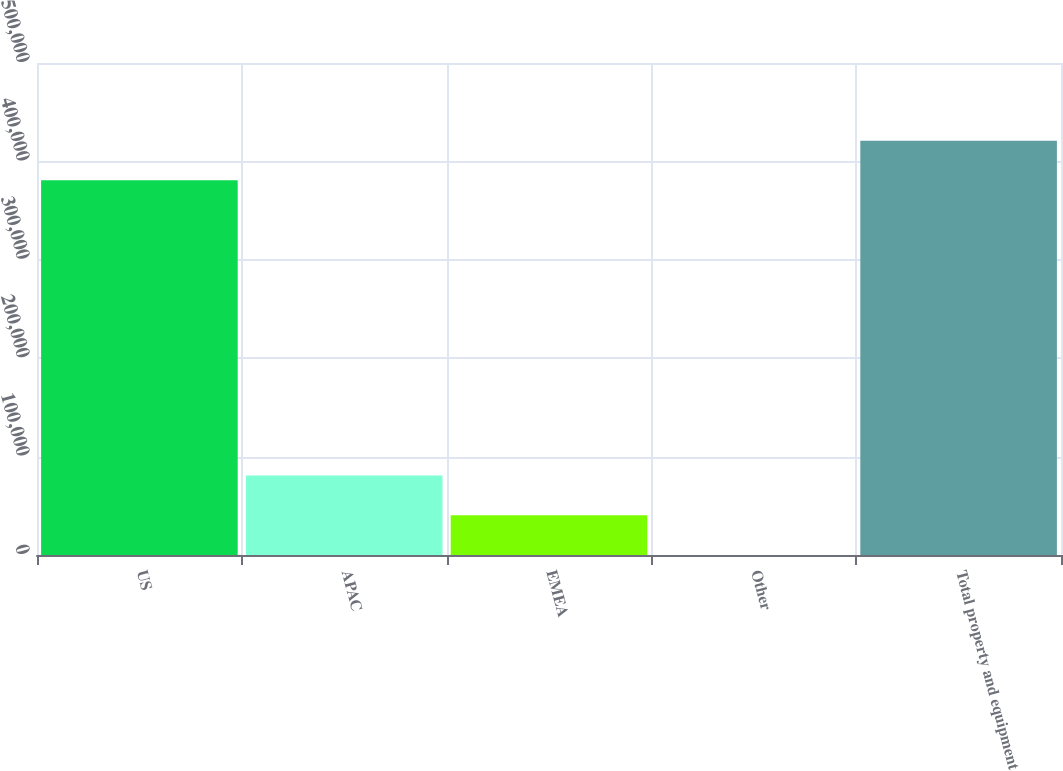<chart> <loc_0><loc_0><loc_500><loc_500><bar_chart><fcel>US<fcel>APAC<fcel>EMEA<fcel>Other<fcel>Total property and equipment<nl><fcel>380732<fcel>80793.8<fcel>40415.4<fcel>37<fcel>421110<nl></chart> 